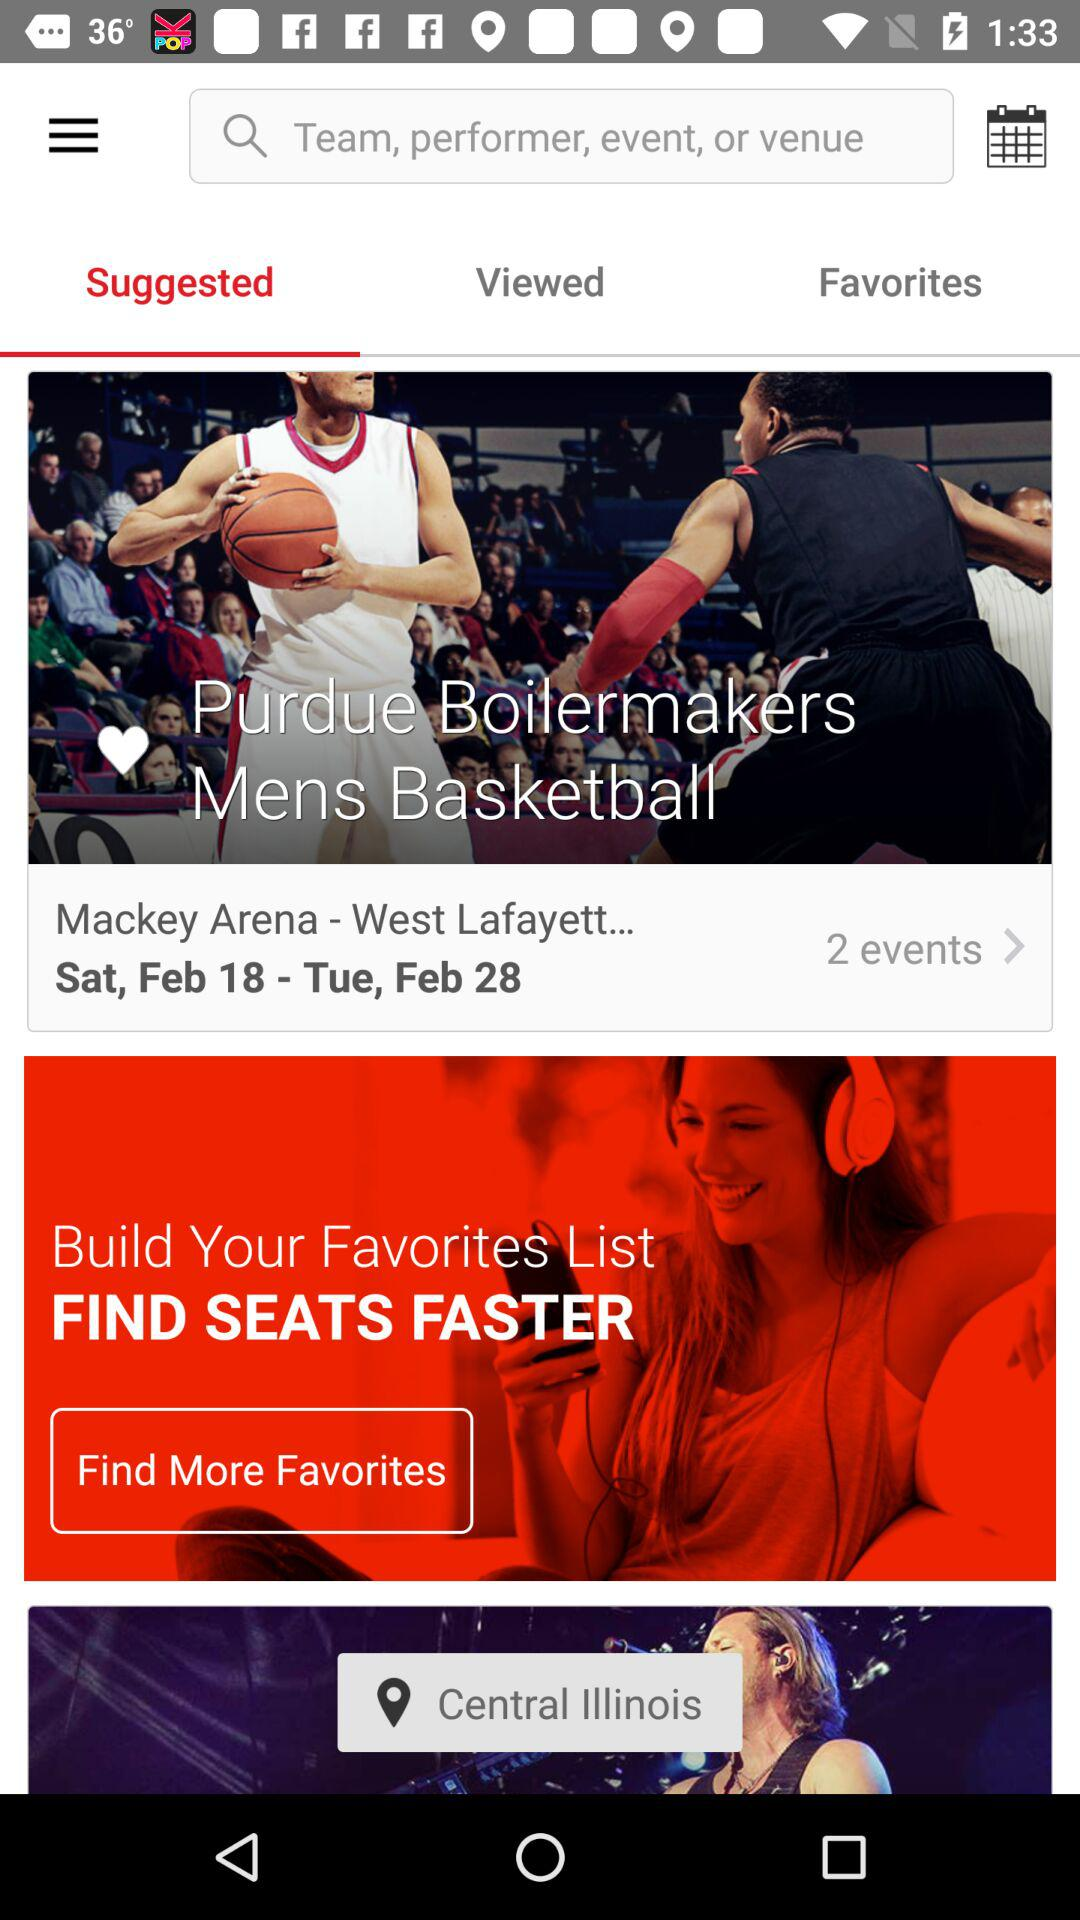How many events are held at "Mackey Arena - West Lafayett..."? There are 2 events held at "Mackey Arena - West Lafayett...". 